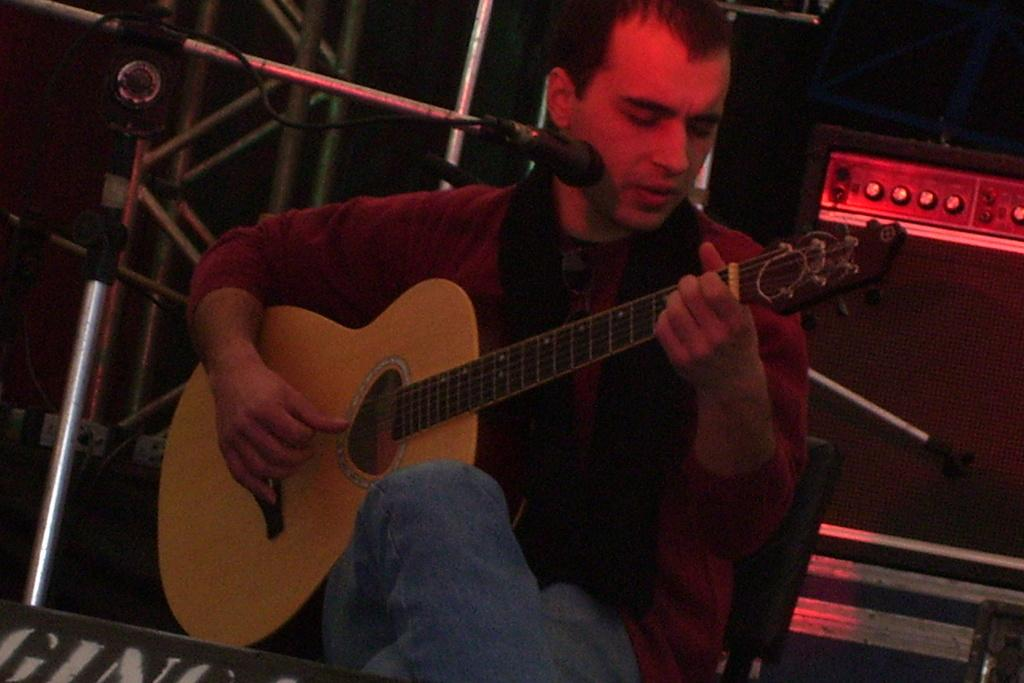What is the man in the image doing? The man is sitting, playing a guitar, and singing. What object is to the left of the man? There is a mic stand with a mic to the left of the man. What can be seen in the background of the image? There is a speaker in the background of the image. What type of quilt is draped over the man's shoulders in the image? There is no quilt present in the image; the man is not wearing or holding any type of quilt. 